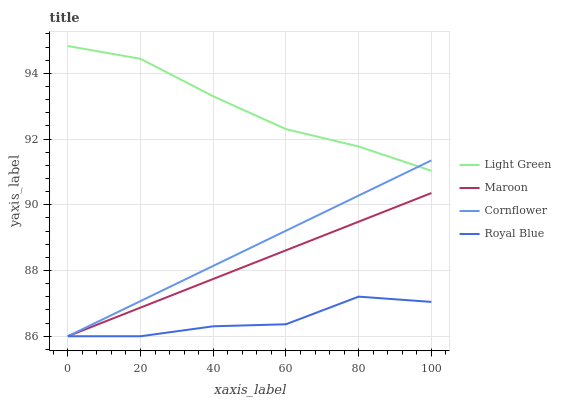Does Royal Blue have the minimum area under the curve?
Answer yes or no. Yes. Does Light Green have the maximum area under the curve?
Answer yes or no. Yes. Does Maroon have the minimum area under the curve?
Answer yes or no. No. Does Maroon have the maximum area under the curve?
Answer yes or no. No. Is Maroon the smoothest?
Answer yes or no. Yes. Is Royal Blue the roughest?
Answer yes or no. Yes. Is Light Green the smoothest?
Answer yes or no. No. Is Light Green the roughest?
Answer yes or no. No. Does Cornflower have the lowest value?
Answer yes or no. Yes. Does Light Green have the lowest value?
Answer yes or no. No. Does Light Green have the highest value?
Answer yes or no. Yes. Does Maroon have the highest value?
Answer yes or no. No. Is Maroon less than Light Green?
Answer yes or no. Yes. Is Light Green greater than Maroon?
Answer yes or no. Yes. Does Royal Blue intersect Maroon?
Answer yes or no. Yes. Is Royal Blue less than Maroon?
Answer yes or no. No. Is Royal Blue greater than Maroon?
Answer yes or no. No. Does Maroon intersect Light Green?
Answer yes or no. No. 